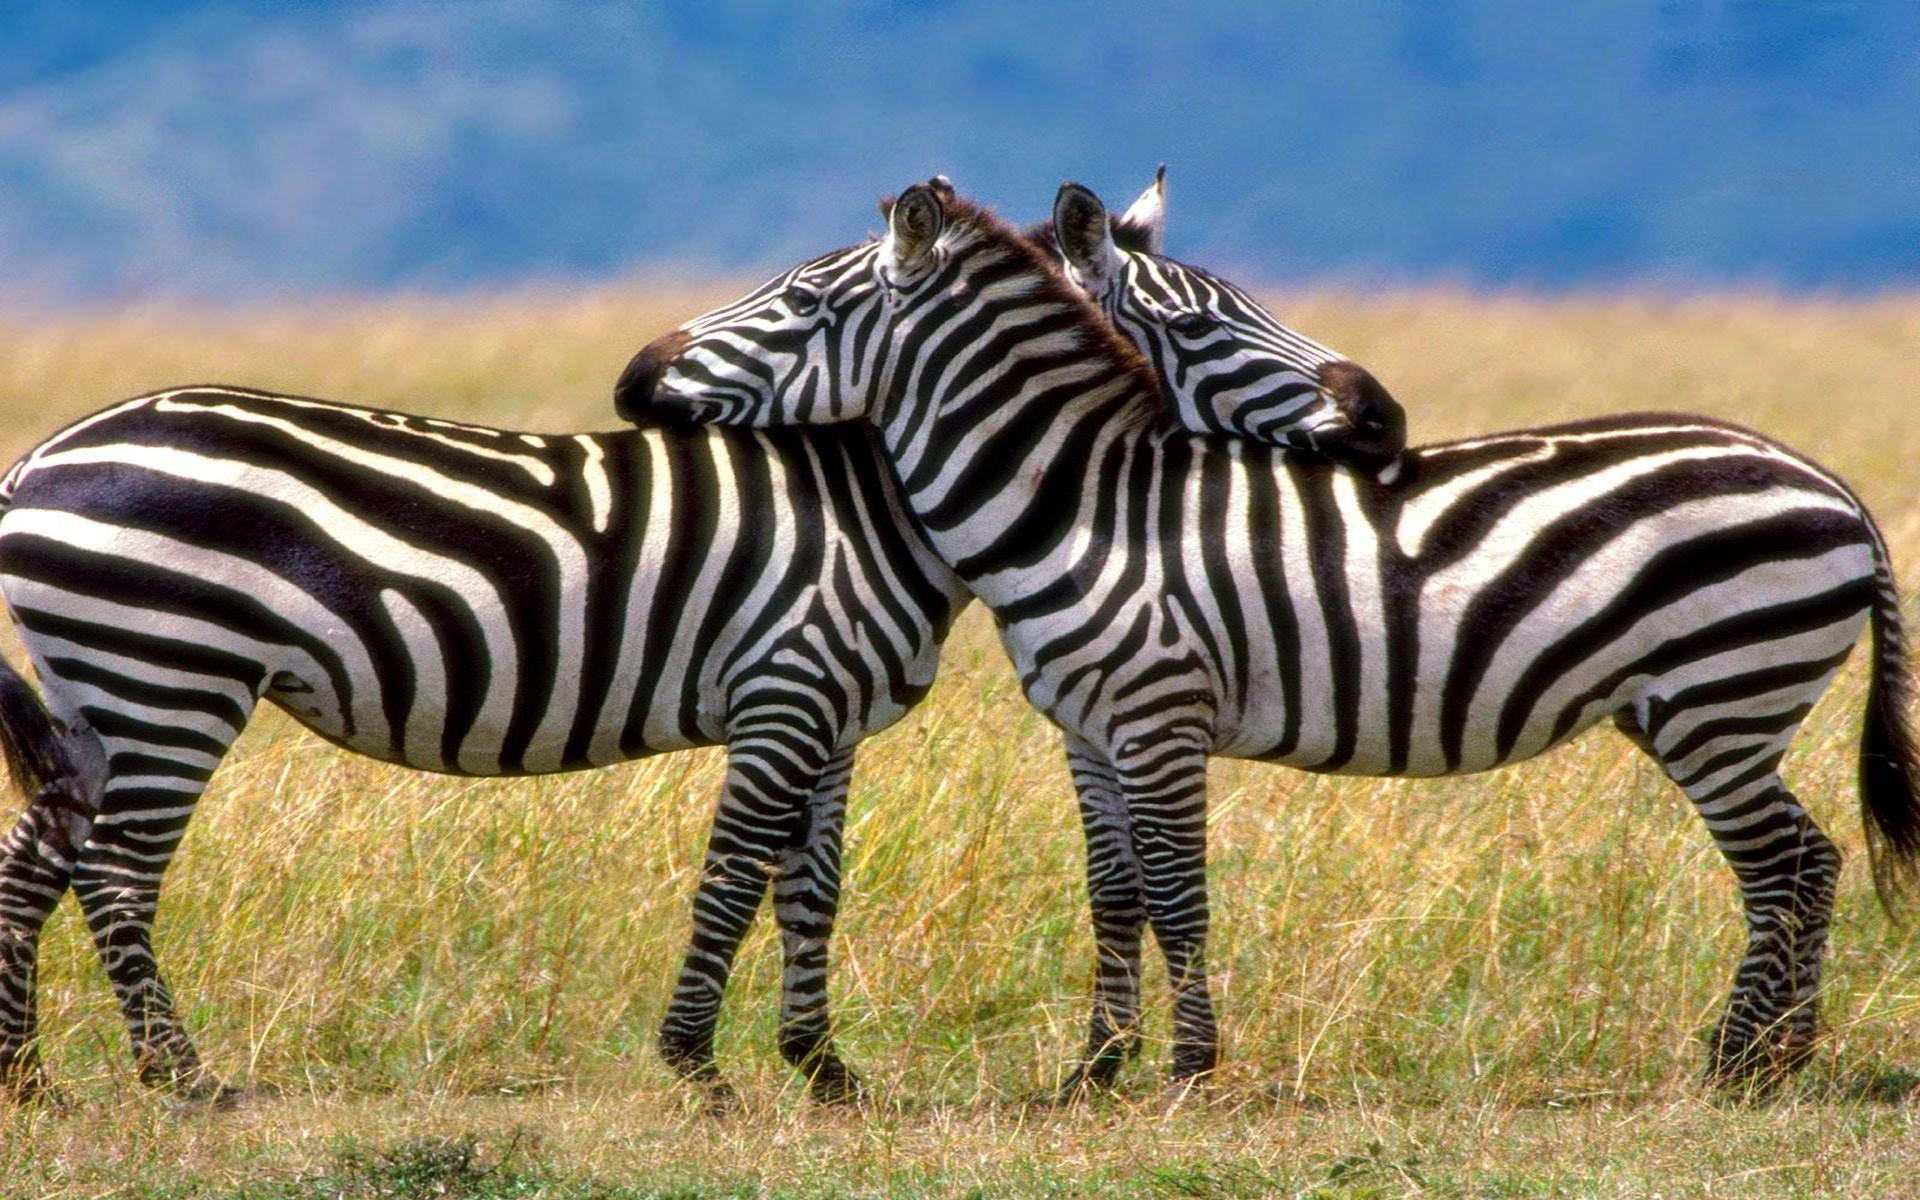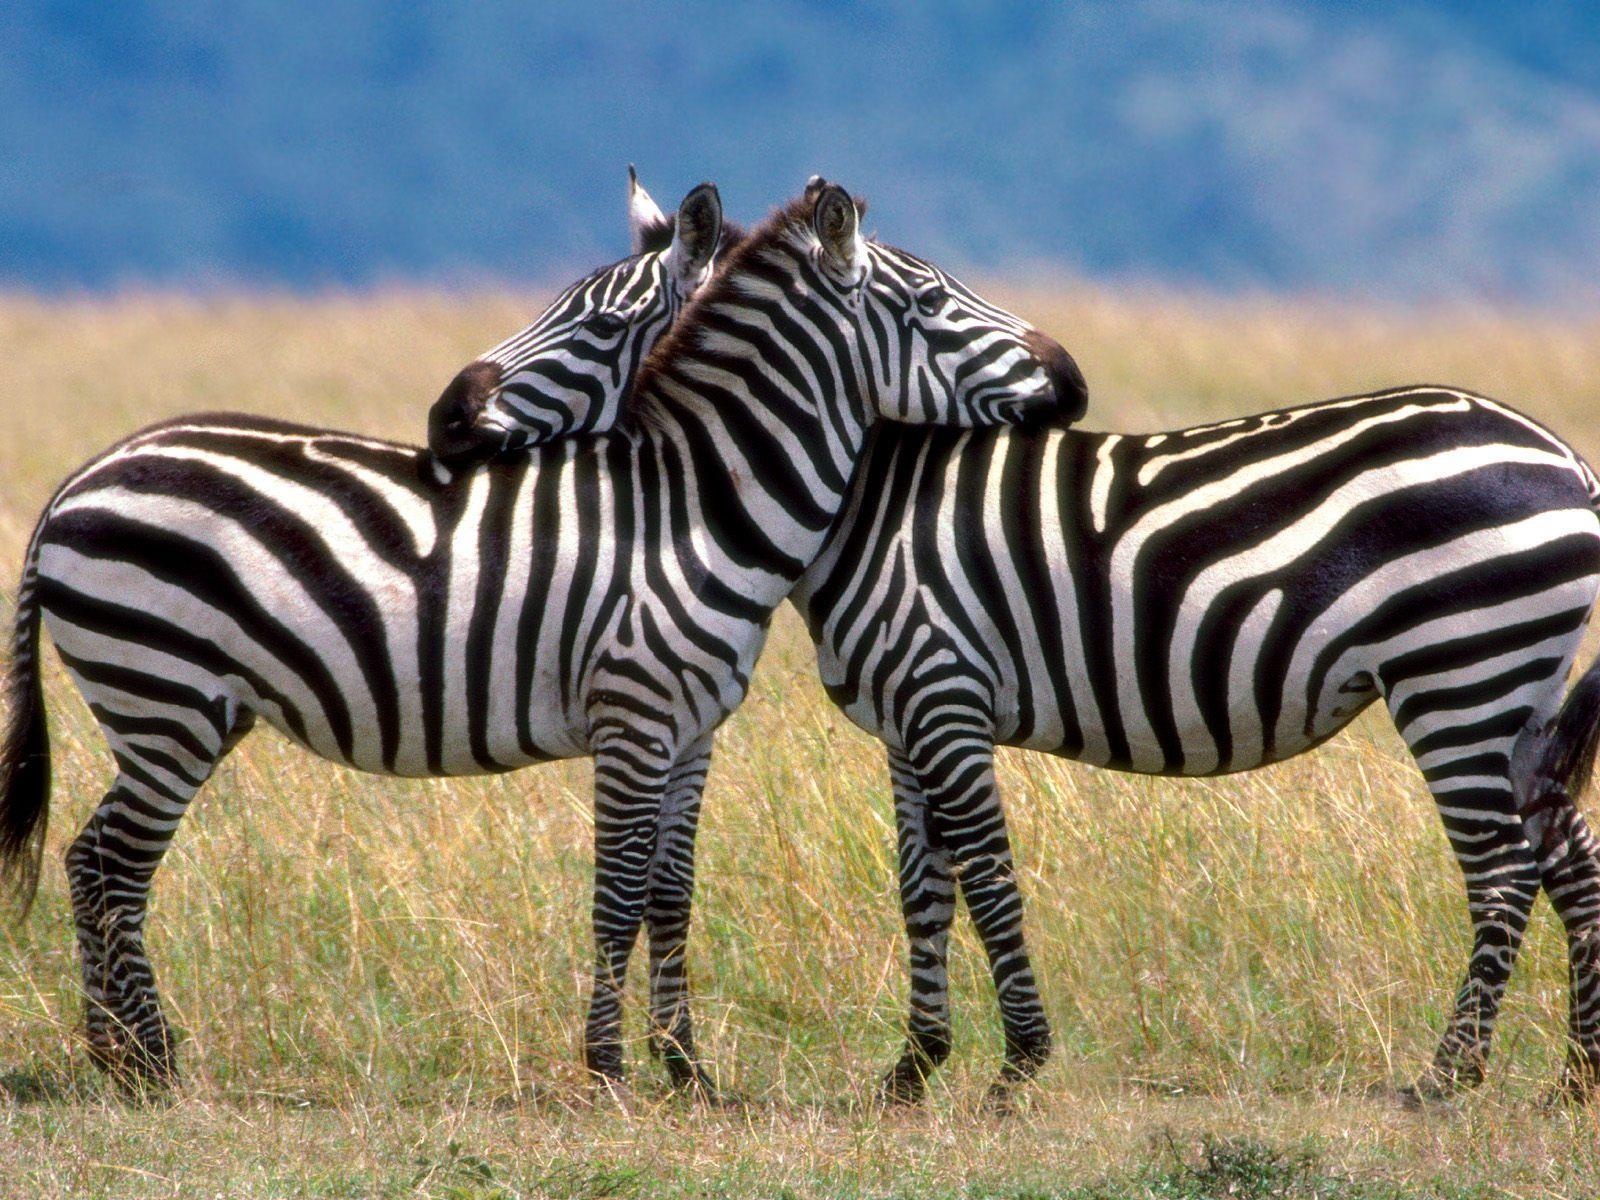The first image is the image on the left, the second image is the image on the right. Evaluate the accuracy of this statement regarding the images: "Each picture shows exactly two zebras.". Is it true? Answer yes or no. Yes. 